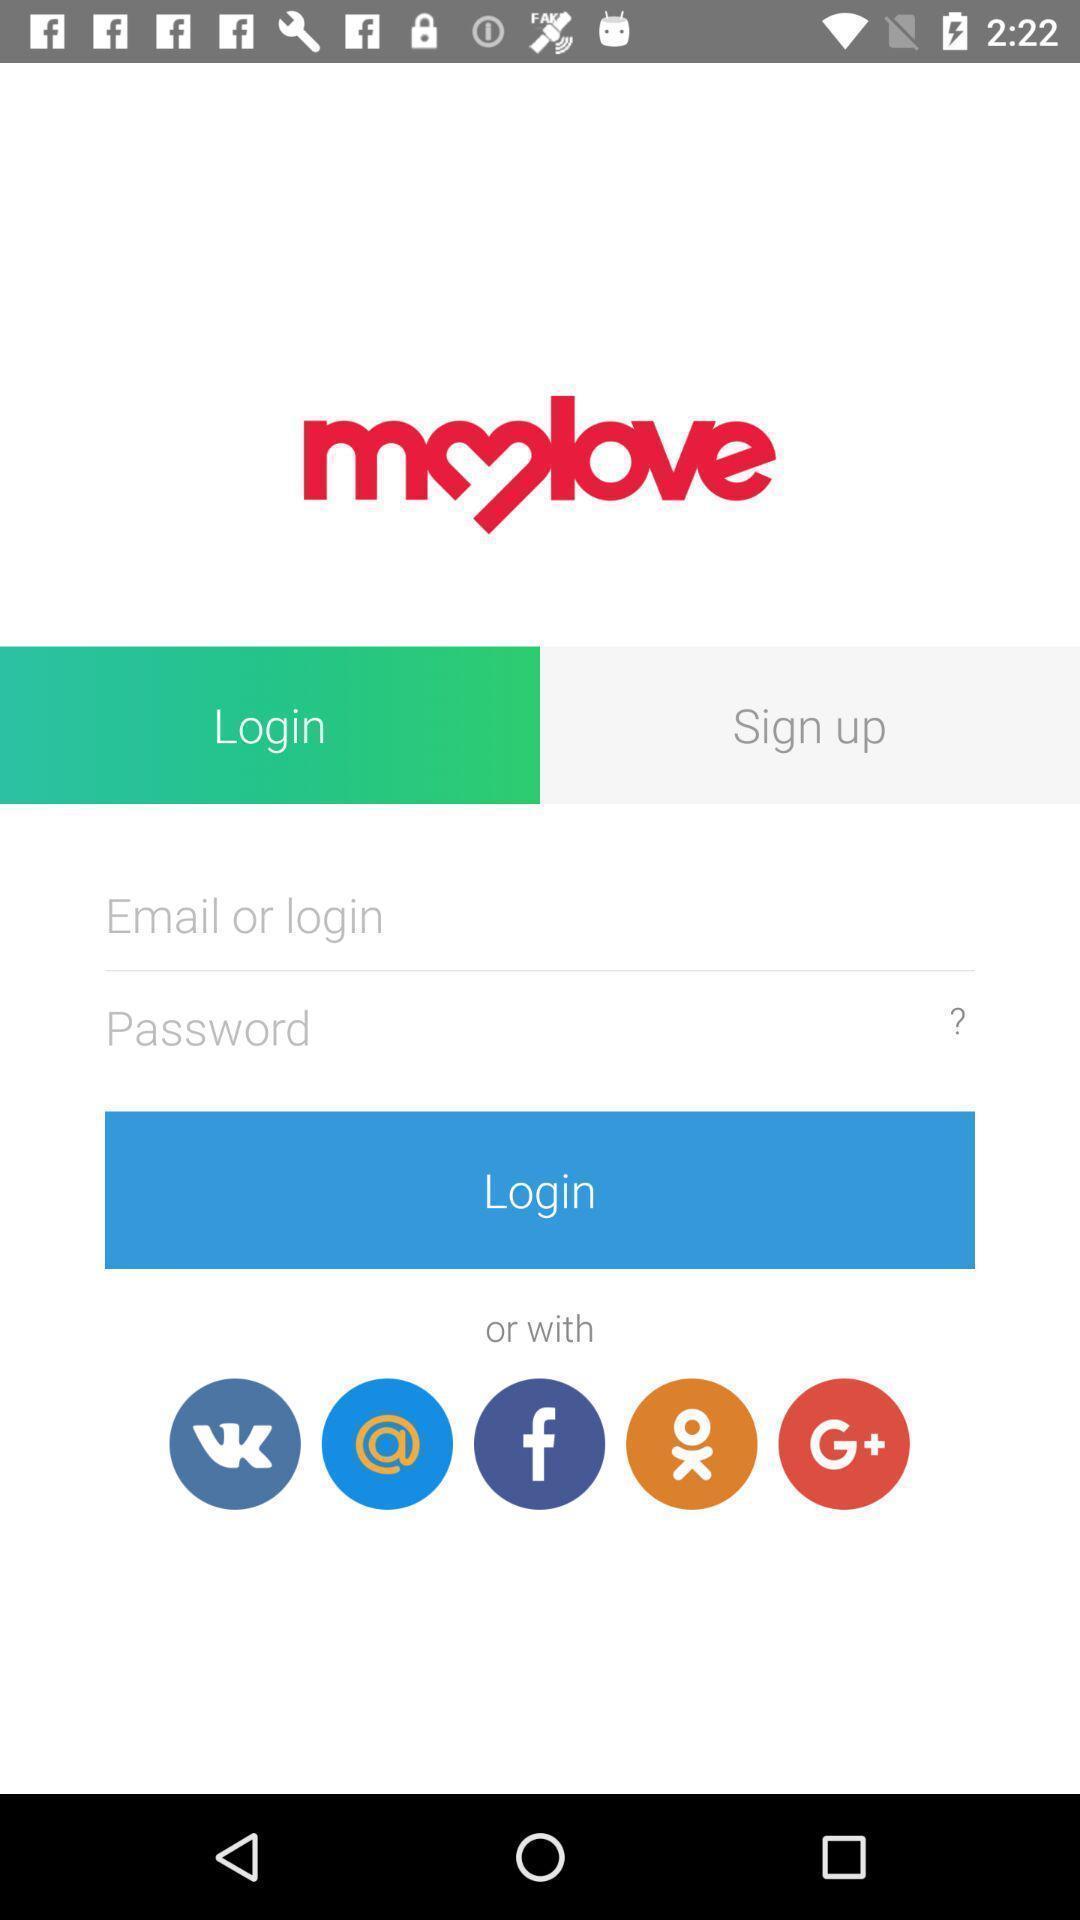Give me a summary of this screen capture. Welcome page displaying to enter details. 